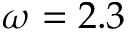<formula> <loc_0><loc_0><loc_500><loc_500>\omega = 2 . 3</formula> 